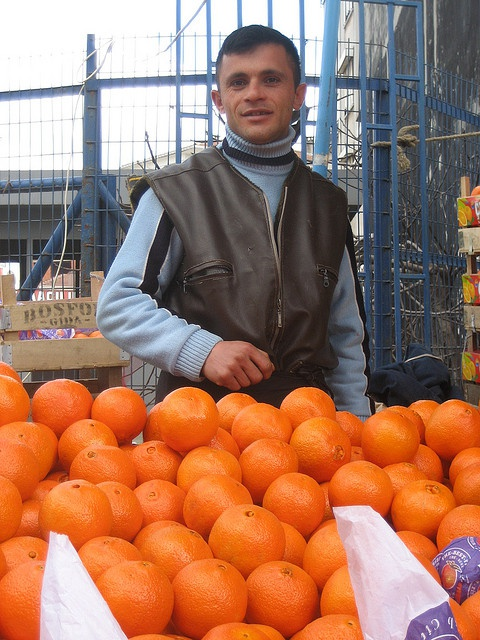Describe the objects in this image and their specific colors. I can see people in white, black, gray, and brown tones, orange in white, red, orange, and brown tones, orange in white, red, salmon, orange, and brown tones, orange in white, red, brown, and salmon tones, and orange in white, red, and orange tones in this image. 